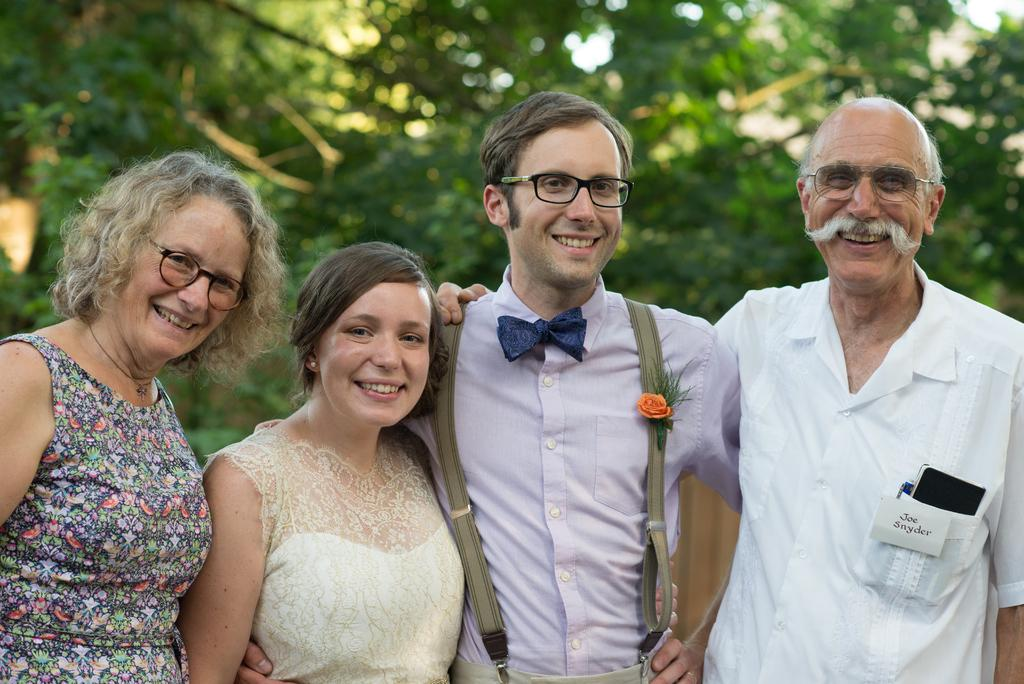What are the people in the image doing? The people in the image are taking pictures. What can be seen in the background of the image? There are trees visible in the background of the image. What type of vegetable is being cooked in the stew in the image? There is no stew or vegetable present in the image; it features people taking pictures with trees in the background. 